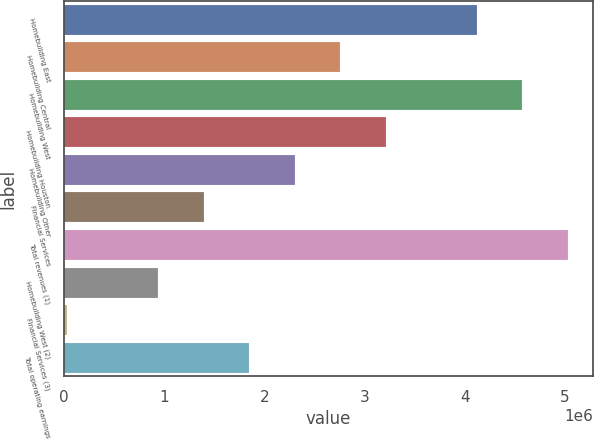<chart> <loc_0><loc_0><loc_500><loc_500><bar_chart><fcel>Homebuilding East<fcel>Homebuilding Central<fcel>Homebuilding West<fcel>Homebuilding Houston<fcel>Homebuilding Other<fcel>Financial Services<fcel>Total revenues (1)<fcel>Homebuilding West (2)<fcel>Financial Services (3)<fcel>Total operating earnings<nl><fcel>4.12097e+06<fcel>2.75765e+06<fcel>4.57542e+06<fcel>3.21209e+06<fcel>2.3032e+06<fcel>1.39432e+06<fcel>5.02986e+06<fcel>939875<fcel>30990<fcel>1.84876e+06<nl></chart> 